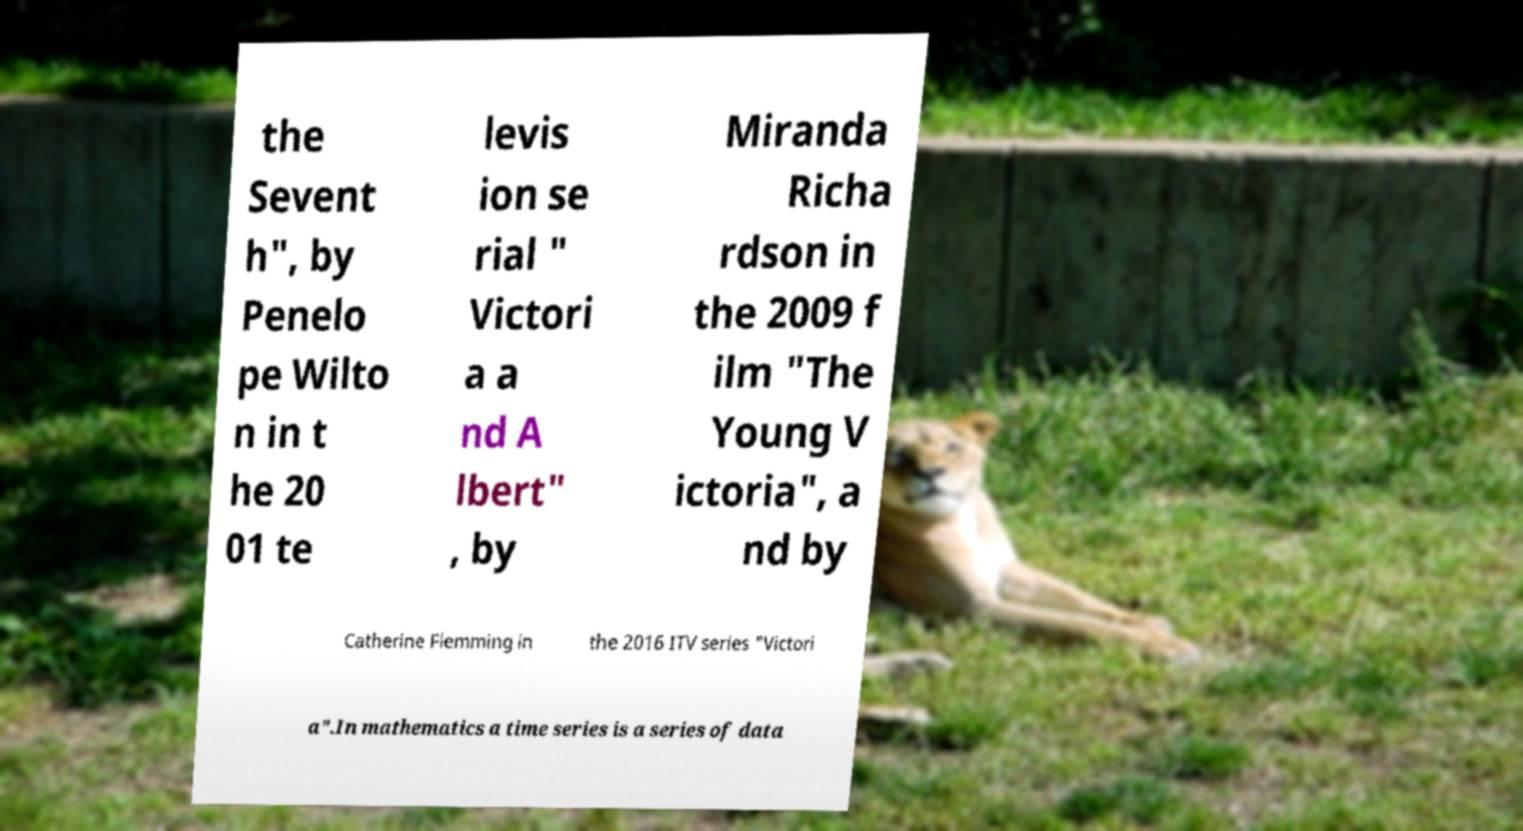Can you accurately transcribe the text from the provided image for me? the Sevent h", by Penelo pe Wilto n in t he 20 01 te levis ion se rial " Victori a a nd A lbert" , by Miranda Richa rdson in the 2009 f ilm "The Young V ictoria", a nd by Catherine Flemming in the 2016 ITV series "Victori a".In mathematics a time series is a series of data 